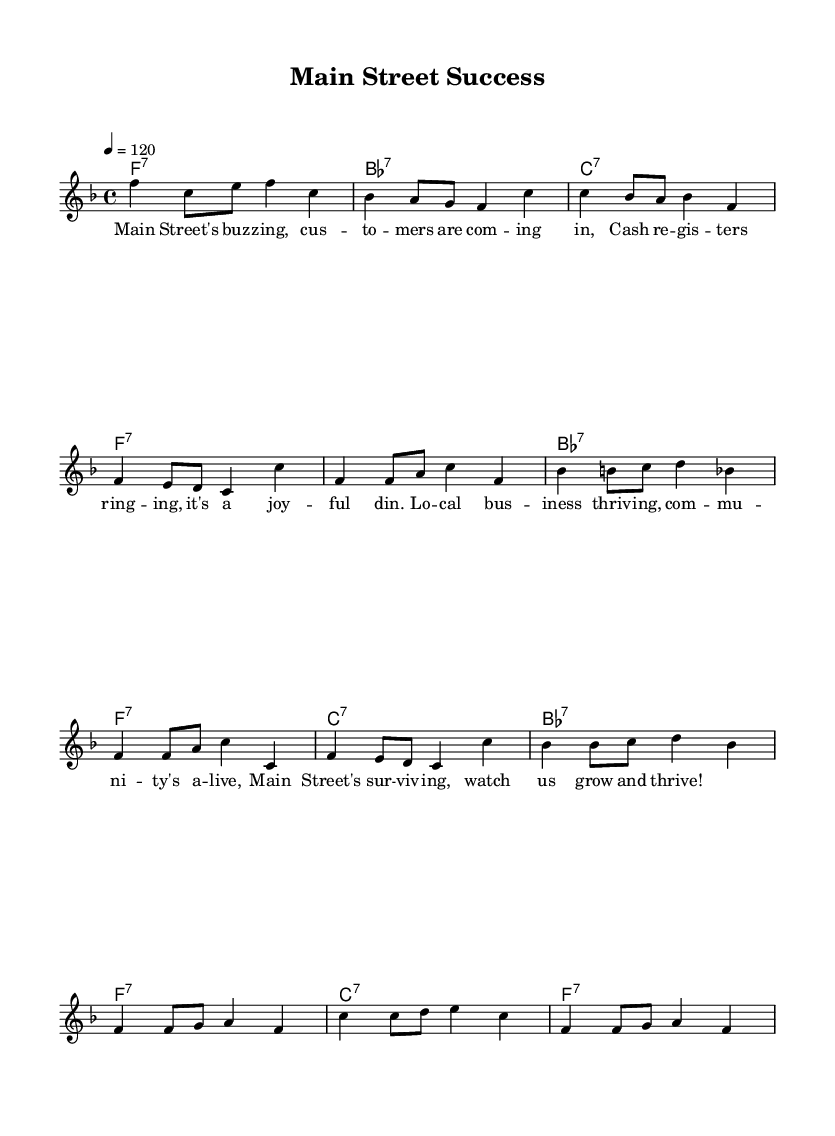What is the key signature of this music? The key signature is F major, which has one flat (B flat). This can be determined by observing the key signature notation, which is located at the beginning of the staff.
Answer: F major What is the time signature of this music? The time signature is 4/4, as indicated at the beginning of the score. This means there are four beats in each measure, and the quarter note gets one beat.
Answer: 4/4 What is the tempo marking for this piece? The tempo marking is 120 beats per minute. This is shown in the tempo indication at the beginning of the score, specifying how fast the piece should be played.
Answer: 120 How many measures are in the chorus? The chorus contains four measures. This is determined by counting the grouped lines under the chorus section in the score.
Answer: 4 measures What type of seventh chords are used in the harmony section? The chords used are dominant seventh chords. This can be seen in the harmonies where each chord is written in the format of root note followed by ":7", indicating they are seventh chords.
Answer: Dominant seventh What main theme is expressed in the lyrics? The main theme expressed in the lyrics is community and business success. The lyrics reference the bustling activity and joy of local businesses thriving on Main Street, which highlights the positive spirit of the community.
Answer: Community and business success How does the structure of this blues piece reflect its upbeat nature? The structure reflects an upbeat nature through its lively tempo, repetitive chord progressions, and positive lyrics that celebrate local successes. The use of a traditional blues form, with verses followed by a chorus, adds to the joyful expression of the theme.
Answer: Upbeat structure through lively tempo and positive celebration 